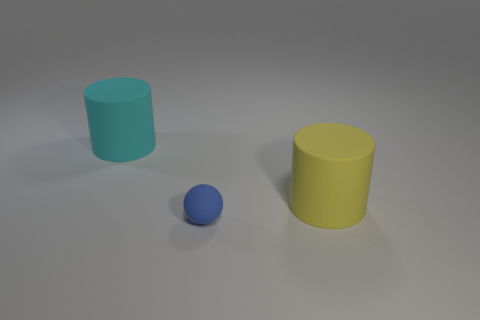Do the yellow matte cylinder and the matte cylinder that is left of the matte ball have the same size?
Your answer should be very brief. Yes. Are there any spheres that have the same size as the cyan rubber object?
Ensure brevity in your answer.  No. What number of other objects are there of the same material as the yellow thing?
Keep it short and to the point. 2. There is a matte object that is both behind the blue rubber thing and to the left of the yellow rubber cylinder; what color is it?
Provide a short and direct response. Cyan. Are the thing that is on the left side of the blue sphere and the big object that is on the right side of the big cyan thing made of the same material?
Give a very brief answer. Yes. There is a blue rubber sphere that is in front of the yellow rubber cylinder; does it have the same size as the large yellow rubber cylinder?
Keep it short and to the point. No. The large cyan object has what shape?
Ensure brevity in your answer.  Cylinder. What number of things are either large cylinders left of the blue object or yellow objects?
Offer a very short reply. 2. What is the size of the cyan object that is made of the same material as the large yellow cylinder?
Give a very brief answer. Large. Are there more large yellow matte cylinders that are behind the blue rubber thing than tiny cyan rubber cylinders?
Ensure brevity in your answer.  Yes. 